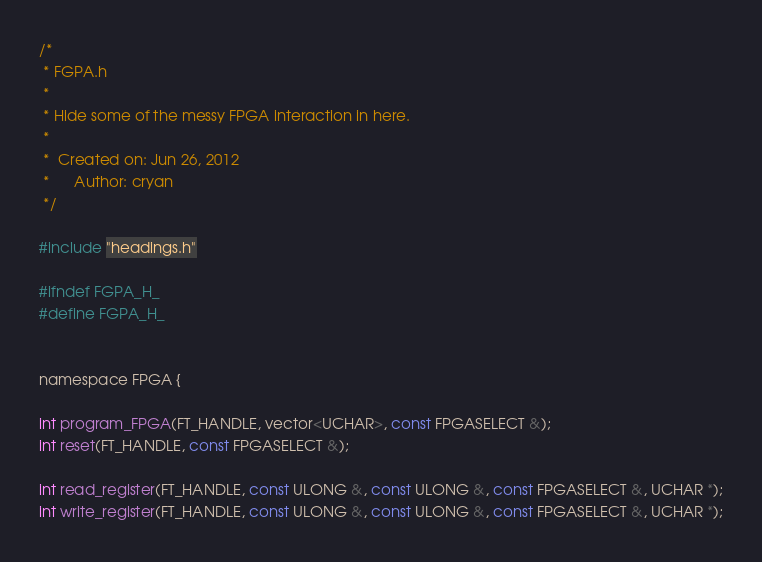Convert code to text. <code><loc_0><loc_0><loc_500><loc_500><_C_>/*
 * FGPA.h
 *
 * Hide some of the messy FPGA interaction in here.
 *
 *  Created on: Jun 26, 2012
 *      Author: cryan
 */

#include "headings.h"

#ifndef FGPA_H_
#define FGPA_H_


namespace FPGA {

int program_FPGA(FT_HANDLE, vector<UCHAR>, const FPGASELECT &);
int reset(FT_HANDLE, const FPGASELECT &);

int read_register(FT_HANDLE, const ULONG &, const ULONG &, const FPGASELECT &, UCHAR *);
int write_register(FT_HANDLE, const ULONG &, const ULONG &, const FPGASELECT &, UCHAR *);
</code> 